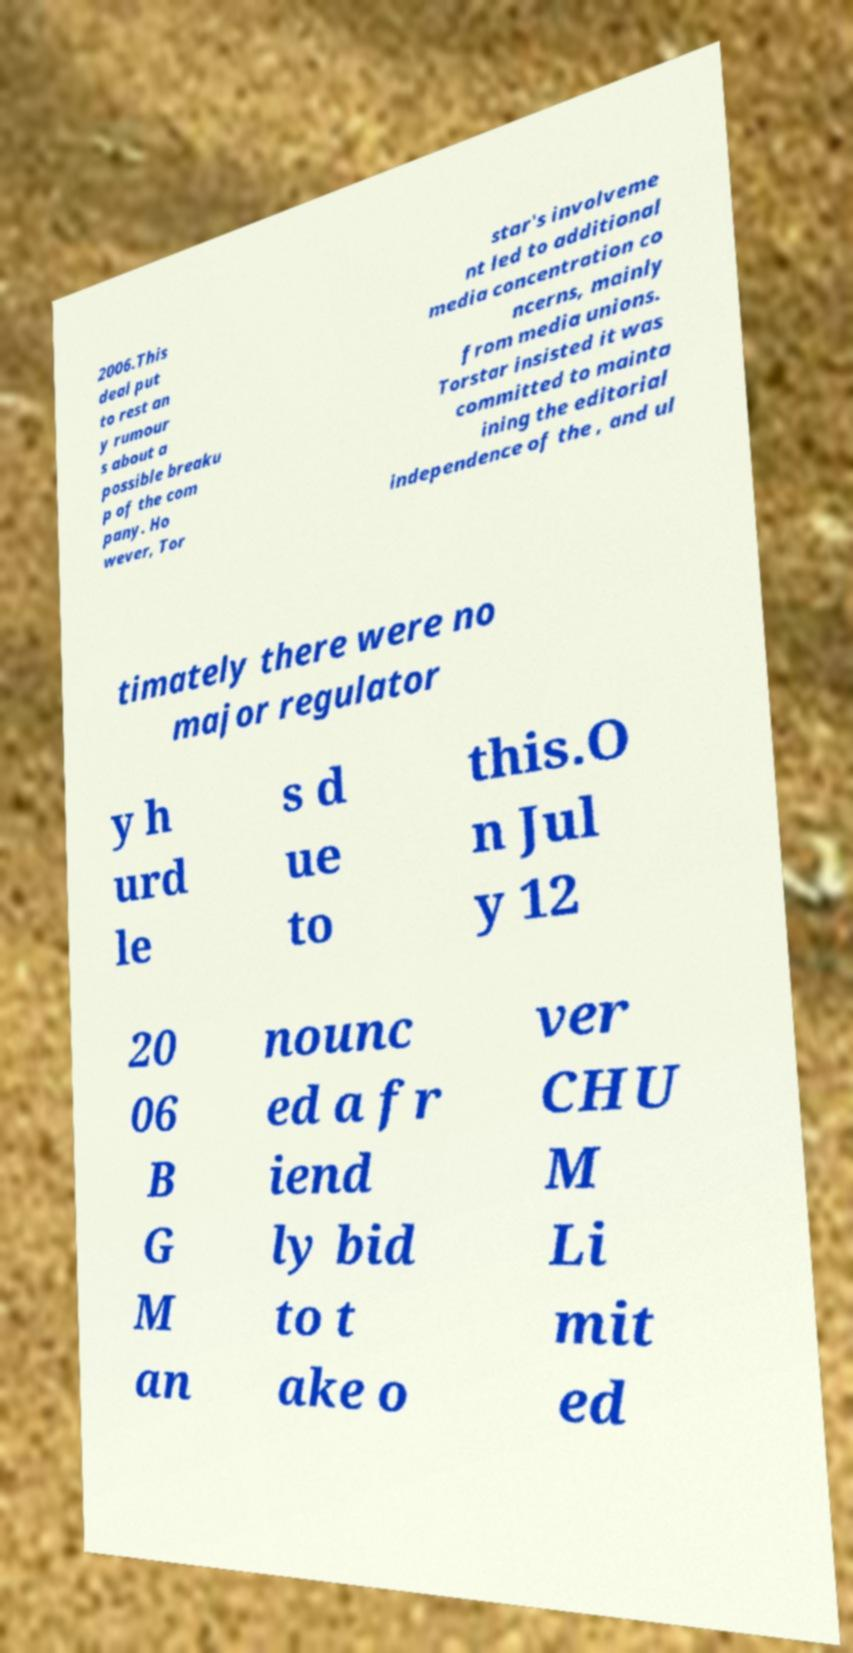Could you assist in decoding the text presented in this image and type it out clearly? 2006.This deal put to rest an y rumour s about a possible breaku p of the com pany. Ho wever, Tor star's involveme nt led to additional media concentration co ncerns, mainly from media unions. Torstar insisted it was committed to mainta ining the editorial independence of the , and ul timately there were no major regulator y h urd le s d ue to this.O n Jul y 12 20 06 B G M an nounc ed a fr iend ly bid to t ake o ver CHU M Li mit ed 